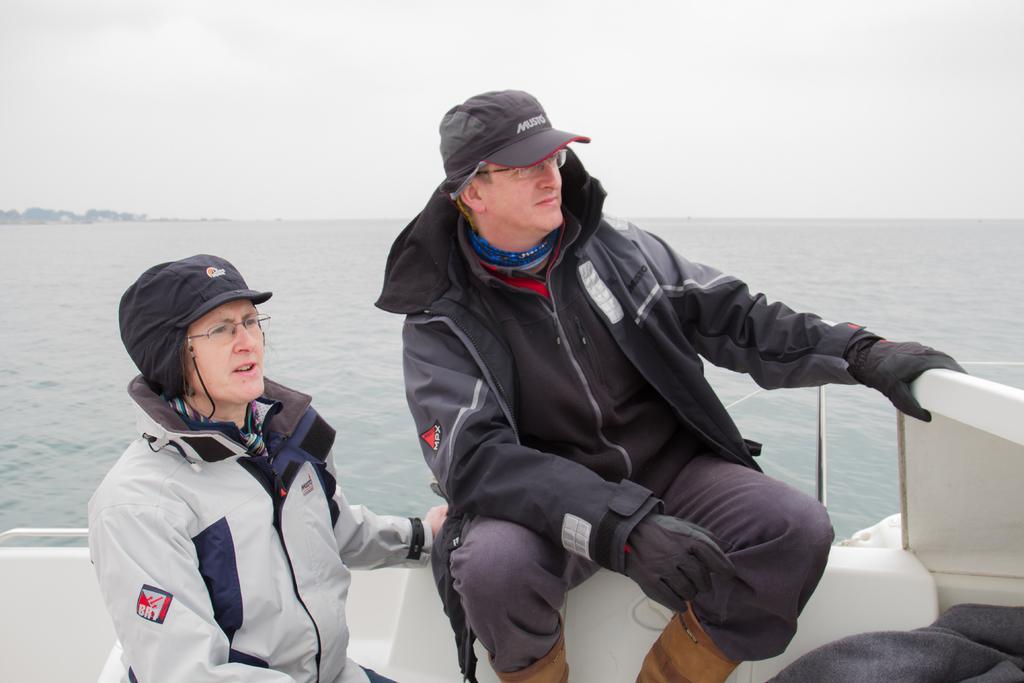How would you summarize this image in a sentence or two? In this image there are two people in a boat an the boat is in the water, there are trees and the sky. 